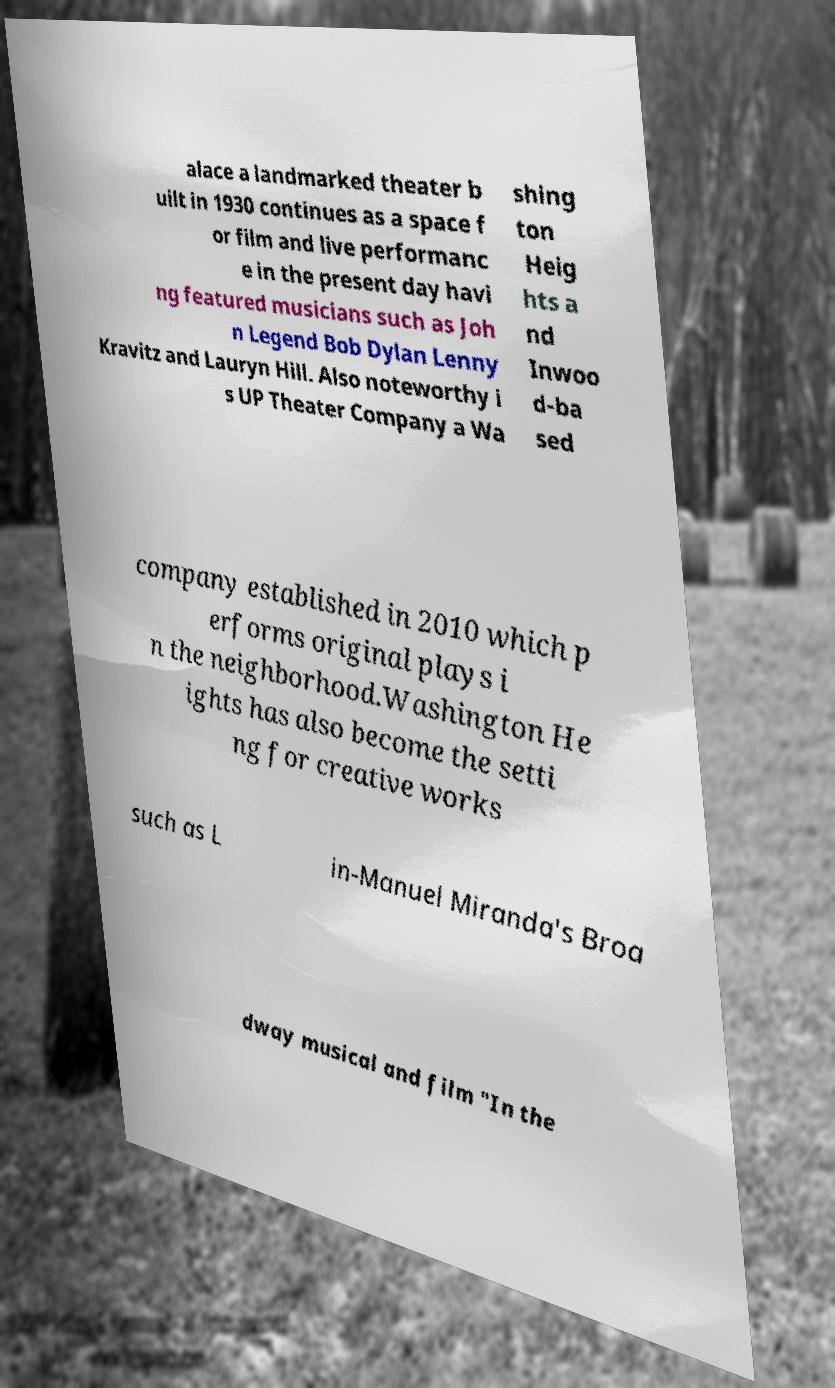There's text embedded in this image that I need extracted. Can you transcribe it verbatim? alace a landmarked theater b uilt in 1930 continues as a space f or film and live performanc e in the present day havi ng featured musicians such as Joh n Legend Bob Dylan Lenny Kravitz and Lauryn Hill. Also noteworthy i s UP Theater Company a Wa shing ton Heig hts a nd Inwoo d-ba sed company established in 2010 which p erforms original plays i n the neighborhood.Washington He ights has also become the setti ng for creative works such as L in-Manuel Miranda's Broa dway musical and film "In the 